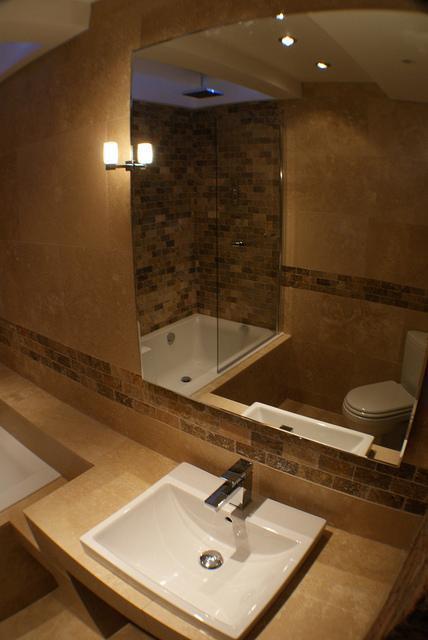Why is there no shower curtain?
From the following four choices, select the correct answer to address the question.
Options: No shower, on floor, no bathtub, shower door. Shower door. 